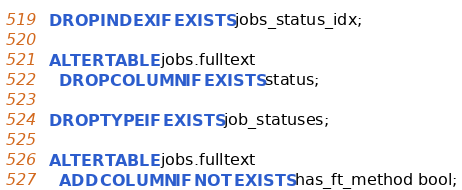<code> <loc_0><loc_0><loc_500><loc_500><_SQL_>DROP INDEX IF EXISTS jobs_status_idx;

ALTER TABLE jobs.fulltext
  DROP COLUMN IF EXISTS status;

DROP TYPE IF EXISTS job_statuses;

ALTER TABLE jobs.fulltext
  ADD COLUMN IF NOT EXISTS has_ft_method bool;

</code> 